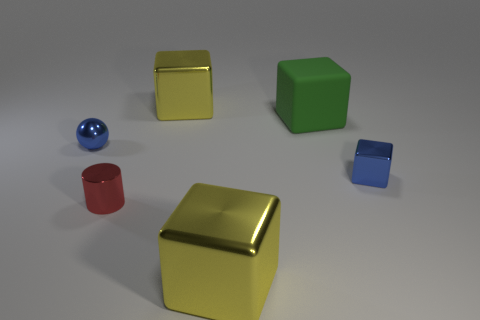What is the big thing that is on the left side of the large metallic object that is to the right of the big yellow block that is behind the matte block made of? metal 